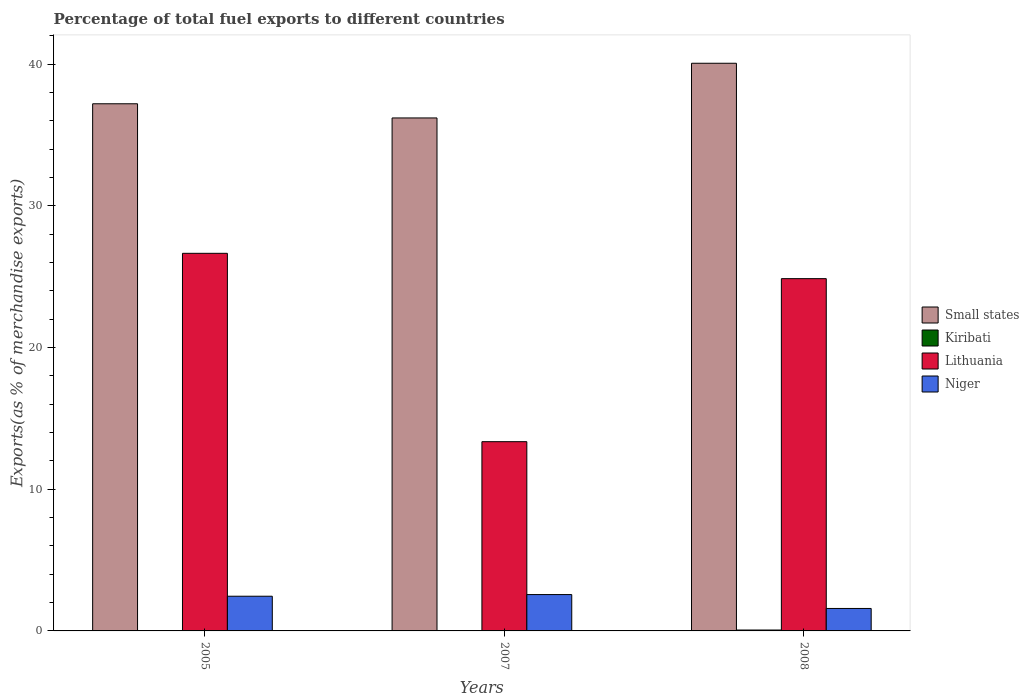How many different coloured bars are there?
Make the answer very short. 4. Are the number of bars per tick equal to the number of legend labels?
Offer a terse response. Yes. How many bars are there on the 3rd tick from the right?
Keep it short and to the point. 4. What is the label of the 2nd group of bars from the left?
Offer a terse response. 2007. In how many cases, is the number of bars for a given year not equal to the number of legend labels?
Offer a very short reply. 0. What is the percentage of exports to different countries in Niger in 2007?
Offer a very short reply. 2.57. Across all years, what is the maximum percentage of exports to different countries in Lithuania?
Keep it short and to the point. 26.65. Across all years, what is the minimum percentage of exports to different countries in Lithuania?
Your response must be concise. 13.36. In which year was the percentage of exports to different countries in Small states maximum?
Provide a short and direct response. 2008. What is the total percentage of exports to different countries in Niger in the graph?
Ensure brevity in your answer.  6.6. What is the difference between the percentage of exports to different countries in Niger in 2005 and that in 2008?
Ensure brevity in your answer.  0.86. What is the difference between the percentage of exports to different countries in Small states in 2007 and the percentage of exports to different countries in Kiribati in 2005?
Offer a terse response. 36.18. What is the average percentage of exports to different countries in Lithuania per year?
Make the answer very short. 21.62. In the year 2008, what is the difference between the percentage of exports to different countries in Niger and percentage of exports to different countries in Small states?
Offer a very short reply. -38.48. In how many years, is the percentage of exports to different countries in Small states greater than 10 %?
Your response must be concise. 3. What is the ratio of the percentage of exports to different countries in Small states in 2005 to that in 2008?
Your answer should be very brief. 0.93. Is the percentage of exports to different countries in Lithuania in 2005 less than that in 2007?
Give a very brief answer. No. Is the difference between the percentage of exports to different countries in Niger in 2005 and 2007 greater than the difference between the percentage of exports to different countries in Small states in 2005 and 2007?
Offer a very short reply. No. What is the difference between the highest and the second highest percentage of exports to different countries in Niger?
Your answer should be compact. 0.12. What is the difference between the highest and the lowest percentage of exports to different countries in Kiribati?
Your response must be concise. 0.06. Is the sum of the percentage of exports to different countries in Lithuania in 2007 and 2008 greater than the maximum percentage of exports to different countries in Kiribati across all years?
Offer a terse response. Yes. Is it the case that in every year, the sum of the percentage of exports to different countries in Small states and percentage of exports to different countries in Niger is greater than the sum of percentage of exports to different countries in Kiribati and percentage of exports to different countries in Lithuania?
Make the answer very short. No. What does the 4th bar from the left in 2005 represents?
Offer a very short reply. Niger. What does the 2nd bar from the right in 2007 represents?
Offer a terse response. Lithuania. Are all the bars in the graph horizontal?
Keep it short and to the point. No. What is the difference between two consecutive major ticks on the Y-axis?
Give a very brief answer. 10. Are the values on the major ticks of Y-axis written in scientific E-notation?
Make the answer very short. No. Does the graph contain any zero values?
Provide a succinct answer. No. Where does the legend appear in the graph?
Give a very brief answer. Center right. How many legend labels are there?
Your response must be concise. 4. How are the legend labels stacked?
Provide a succinct answer. Vertical. What is the title of the graph?
Provide a short and direct response. Percentage of total fuel exports to different countries. What is the label or title of the Y-axis?
Provide a short and direct response. Exports(as % of merchandise exports). What is the Exports(as % of merchandise exports) in Small states in 2005?
Make the answer very short. 37.2. What is the Exports(as % of merchandise exports) in Kiribati in 2005?
Make the answer very short. 0.02. What is the Exports(as % of merchandise exports) in Lithuania in 2005?
Offer a very short reply. 26.65. What is the Exports(as % of merchandise exports) of Niger in 2005?
Ensure brevity in your answer.  2.45. What is the Exports(as % of merchandise exports) in Small states in 2007?
Make the answer very short. 36.2. What is the Exports(as % of merchandise exports) in Kiribati in 2007?
Provide a short and direct response. 0. What is the Exports(as % of merchandise exports) in Lithuania in 2007?
Ensure brevity in your answer.  13.36. What is the Exports(as % of merchandise exports) in Niger in 2007?
Provide a succinct answer. 2.57. What is the Exports(as % of merchandise exports) in Small states in 2008?
Give a very brief answer. 40.06. What is the Exports(as % of merchandise exports) of Kiribati in 2008?
Keep it short and to the point. 0.06. What is the Exports(as % of merchandise exports) of Lithuania in 2008?
Offer a terse response. 24.86. What is the Exports(as % of merchandise exports) in Niger in 2008?
Your answer should be compact. 1.59. Across all years, what is the maximum Exports(as % of merchandise exports) of Small states?
Provide a short and direct response. 40.06. Across all years, what is the maximum Exports(as % of merchandise exports) of Kiribati?
Offer a very short reply. 0.06. Across all years, what is the maximum Exports(as % of merchandise exports) of Lithuania?
Your answer should be compact. 26.65. Across all years, what is the maximum Exports(as % of merchandise exports) of Niger?
Give a very brief answer. 2.57. Across all years, what is the minimum Exports(as % of merchandise exports) in Small states?
Offer a terse response. 36.2. Across all years, what is the minimum Exports(as % of merchandise exports) of Kiribati?
Make the answer very short. 0. Across all years, what is the minimum Exports(as % of merchandise exports) of Lithuania?
Ensure brevity in your answer.  13.36. Across all years, what is the minimum Exports(as % of merchandise exports) of Niger?
Offer a very short reply. 1.59. What is the total Exports(as % of merchandise exports) of Small states in the graph?
Offer a terse response. 113.46. What is the total Exports(as % of merchandise exports) in Kiribati in the graph?
Offer a terse response. 0.08. What is the total Exports(as % of merchandise exports) of Lithuania in the graph?
Keep it short and to the point. 64.86. What is the total Exports(as % of merchandise exports) in Niger in the graph?
Your answer should be very brief. 6.6. What is the difference between the Exports(as % of merchandise exports) in Small states in 2005 and that in 2007?
Provide a succinct answer. 1. What is the difference between the Exports(as % of merchandise exports) of Kiribati in 2005 and that in 2007?
Make the answer very short. 0.02. What is the difference between the Exports(as % of merchandise exports) of Lithuania in 2005 and that in 2007?
Provide a succinct answer. 13.29. What is the difference between the Exports(as % of merchandise exports) of Niger in 2005 and that in 2007?
Provide a short and direct response. -0.12. What is the difference between the Exports(as % of merchandise exports) in Small states in 2005 and that in 2008?
Offer a terse response. -2.86. What is the difference between the Exports(as % of merchandise exports) of Kiribati in 2005 and that in 2008?
Offer a very short reply. -0.05. What is the difference between the Exports(as % of merchandise exports) in Lithuania in 2005 and that in 2008?
Provide a succinct answer. 1.79. What is the difference between the Exports(as % of merchandise exports) in Niger in 2005 and that in 2008?
Ensure brevity in your answer.  0.86. What is the difference between the Exports(as % of merchandise exports) in Small states in 2007 and that in 2008?
Your answer should be very brief. -3.86. What is the difference between the Exports(as % of merchandise exports) in Kiribati in 2007 and that in 2008?
Your response must be concise. -0.06. What is the difference between the Exports(as % of merchandise exports) of Lithuania in 2007 and that in 2008?
Give a very brief answer. -11.5. What is the difference between the Exports(as % of merchandise exports) of Niger in 2007 and that in 2008?
Provide a short and direct response. 0.98. What is the difference between the Exports(as % of merchandise exports) in Small states in 2005 and the Exports(as % of merchandise exports) in Kiribati in 2007?
Your answer should be compact. 37.2. What is the difference between the Exports(as % of merchandise exports) of Small states in 2005 and the Exports(as % of merchandise exports) of Lithuania in 2007?
Provide a short and direct response. 23.85. What is the difference between the Exports(as % of merchandise exports) in Small states in 2005 and the Exports(as % of merchandise exports) in Niger in 2007?
Offer a terse response. 34.64. What is the difference between the Exports(as % of merchandise exports) in Kiribati in 2005 and the Exports(as % of merchandise exports) in Lithuania in 2007?
Give a very brief answer. -13.34. What is the difference between the Exports(as % of merchandise exports) of Kiribati in 2005 and the Exports(as % of merchandise exports) of Niger in 2007?
Offer a terse response. -2.55. What is the difference between the Exports(as % of merchandise exports) in Lithuania in 2005 and the Exports(as % of merchandise exports) in Niger in 2007?
Your answer should be very brief. 24.08. What is the difference between the Exports(as % of merchandise exports) of Small states in 2005 and the Exports(as % of merchandise exports) of Kiribati in 2008?
Ensure brevity in your answer.  37.14. What is the difference between the Exports(as % of merchandise exports) of Small states in 2005 and the Exports(as % of merchandise exports) of Lithuania in 2008?
Ensure brevity in your answer.  12.34. What is the difference between the Exports(as % of merchandise exports) in Small states in 2005 and the Exports(as % of merchandise exports) in Niger in 2008?
Offer a terse response. 35.62. What is the difference between the Exports(as % of merchandise exports) in Kiribati in 2005 and the Exports(as % of merchandise exports) in Lithuania in 2008?
Offer a very short reply. -24.84. What is the difference between the Exports(as % of merchandise exports) of Kiribati in 2005 and the Exports(as % of merchandise exports) of Niger in 2008?
Offer a very short reply. -1.57. What is the difference between the Exports(as % of merchandise exports) in Lithuania in 2005 and the Exports(as % of merchandise exports) in Niger in 2008?
Your response must be concise. 25.06. What is the difference between the Exports(as % of merchandise exports) in Small states in 2007 and the Exports(as % of merchandise exports) in Kiribati in 2008?
Offer a very short reply. 36.14. What is the difference between the Exports(as % of merchandise exports) in Small states in 2007 and the Exports(as % of merchandise exports) in Lithuania in 2008?
Make the answer very short. 11.34. What is the difference between the Exports(as % of merchandise exports) in Small states in 2007 and the Exports(as % of merchandise exports) in Niger in 2008?
Provide a short and direct response. 34.62. What is the difference between the Exports(as % of merchandise exports) in Kiribati in 2007 and the Exports(as % of merchandise exports) in Lithuania in 2008?
Keep it short and to the point. -24.86. What is the difference between the Exports(as % of merchandise exports) in Kiribati in 2007 and the Exports(as % of merchandise exports) in Niger in 2008?
Provide a short and direct response. -1.59. What is the difference between the Exports(as % of merchandise exports) of Lithuania in 2007 and the Exports(as % of merchandise exports) of Niger in 2008?
Offer a terse response. 11.77. What is the average Exports(as % of merchandise exports) of Small states per year?
Offer a terse response. 37.82. What is the average Exports(as % of merchandise exports) of Kiribati per year?
Give a very brief answer. 0.03. What is the average Exports(as % of merchandise exports) in Lithuania per year?
Offer a terse response. 21.62. What is the average Exports(as % of merchandise exports) in Niger per year?
Ensure brevity in your answer.  2.2. In the year 2005, what is the difference between the Exports(as % of merchandise exports) of Small states and Exports(as % of merchandise exports) of Kiribati?
Your answer should be very brief. 37.18. In the year 2005, what is the difference between the Exports(as % of merchandise exports) of Small states and Exports(as % of merchandise exports) of Lithuania?
Offer a terse response. 10.55. In the year 2005, what is the difference between the Exports(as % of merchandise exports) in Small states and Exports(as % of merchandise exports) in Niger?
Your response must be concise. 34.75. In the year 2005, what is the difference between the Exports(as % of merchandise exports) in Kiribati and Exports(as % of merchandise exports) in Lithuania?
Ensure brevity in your answer.  -26.63. In the year 2005, what is the difference between the Exports(as % of merchandise exports) in Kiribati and Exports(as % of merchandise exports) in Niger?
Your response must be concise. -2.43. In the year 2005, what is the difference between the Exports(as % of merchandise exports) of Lithuania and Exports(as % of merchandise exports) of Niger?
Offer a very short reply. 24.2. In the year 2007, what is the difference between the Exports(as % of merchandise exports) in Small states and Exports(as % of merchandise exports) in Kiribati?
Provide a short and direct response. 36.2. In the year 2007, what is the difference between the Exports(as % of merchandise exports) of Small states and Exports(as % of merchandise exports) of Lithuania?
Provide a succinct answer. 22.85. In the year 2007, what is the difference between the Exports(as % of merchandise exports) in Small states and Exports(as % of merchandise exports) in Niger?
Provide a short and direct response. 33.64. In the year 2007, what is the difference between the Exports(as % of merchandise exports) in Kiribati and Exports(as % of merchandise exports) in Lithuania?
Give a very brief answer. -13.36. In the year 2007, what is the difference between the Exports(as % of merchandise exports) in Kiribati and Exports(as % of merchandise exports) in Niger?
Your answer should be compact. -2.56. In the year 2007, what is the difference between the Exports(as % of merchandise exports) of Lithuania and Exports(as % of merchandise exports) of Niger?
Your answer should be very brief. 10.79. In the year 2008, what is the difference between the Exports(as % of merchandise exports) in Small states and Exports(as % of merchandise exports) in Kiribati?
Provide a succinct answer. 40. In the year 2008, what is the difference between the Exports(as % of merchandise exports) of Small states and Exports(as % of merchandise exports) of Lithuania?
Provide a succinct answer. 15.2. In the year 2008, what is the difference between the Exports(as % of merchandise exports) of Small states and Exports(as % of merchandise exports) of Niger?
Give a very brief answer. 38.48. In the year 2008, what is the difference between the Exports(as % of merchandise exports) of Kiribati and Exports(as % of merchandise exports) of Lithuania?
Ensure brevity in your answer.  -24.8. In the year 2008, what is the difference between the Exports(as % of merchandise exports) in Kiribati and Exports(as % of merchandise exports) in Niger?
Provide a short and direct response. -1.52. In the year 2008, what is the difference between the Exports(as % of merchandise exports) in Lithuania and Exports(as % of merchandise exports) in Niger?
Your answer should be compact. 23.27. What is the ratio of the Exports(as % of merchandise exports) in Small states in 2005 to that in 2007?
Provide a succinct answer. 1.03. What is the ratio of the Exports(as % of merchandise exports) of Kiribati in 2005 to that in 2007?
Offer a very short reply. 69.38. What is the ratio of the Exports(as % of merchandise exports) of Lithuania in 2005 to that in 2007?
Provide a succinct answer. 2. What is the ratio of the Exports(as % of merchandise exports) in Niger in 2005 to that in 2007?
Keep it short and to the point. 0.95. What is the ratio of the Exports(as % of merchandise exports) in Small states in 2005 to that in 2008?
Provide a short and direct response. 0.93. What is the ratio of the Exports(as % of merchandise exports) in Kiribati in 2005 to that in 2008?
Provide a short and direct response. 0.27. What is the ratio of the Exports(as % of merchandise exports) in Lithuania in 2005 to that in 2008?
Give a very brief answer. 1.07. What is the ratio of the Exports(as % of merchandise exports) in Niger in 2005 to that in 2008?
Provide a short and direct response. 1.54. What is the ratio of the Exports(as % of merchandise exports) in Small states in 2007 to that in 2008?
Provide a succinct answer. 0.9. What is the ratio of the Exports(as % of merchandise exports) in Kiribati in 2007 to that in 2008?
Ensure brevity in your answer.  0. What is the ratio of the Exports(as % of merchandise exports) of Lithuania in 2007 to that in 2008?
Ensure brevity in your answer.  0.54. What is the ratio of the Exports(as % of merchandise exports) of Niger in 2007 to that in 2008?
Provide a short and direct response. 1.62. What is the difference between the highest and the second highest Exports(as % of merchandise exports) in Small states?
Make the answer very short. 2.86. What is the difference between the highest and the second highest Exports(as % of merchandise exports) in Kiribati?
Offer a terse response. 0.05. What is the difference between the highest and the second highest Exports(as % of merchandise exports) of Lithuania?
Offer a terse response. 1.79. What is the difference between the highest and the second highest Exports(as % of merchandise exports) of Niger?
Your answer should be compact. 0.12. What is the difference between the highest and the lowest Exports(as % of merchandise exports) of Small states?
Offer a terse response. 3.86. What is the difference between the highest and the lowest Exports(as % of merchandise exports) in Kiribati?
Offer a very short reply. 0.06. What is the difference between the highest and the lowest Exports(as % of merchandise exports) in Lithuania?
Provide a succinct answer. 13.29. What is the difference between the highest and the lowest Exports(as % of merchandise exports) in Niger?
Provide a short and direct response. 0.98. 